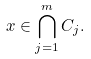Convert formula to latex. <formula><loc_0><loc_0><loc_500><loc_500>x \in \bigcap _ { j = 1 } ^ { m } C _ { j } .</formula> 